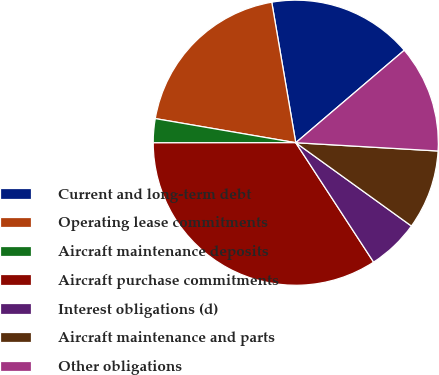Convert chart to OTSL. <chart><loc_0><loc_0><loc_500><loc_500><pie_chart><fcel>Current and long-term debt<fcel>Operating lease commitments<fcel>Aircraft maintenance deposits<fcel>Aircraft purchase commitments<fcel>Interest obligations (d)<fcel>Aircraft maintenance and parts<fcel>Other obligations<nl><fcel>16.46%<fcel>19.6%<fcel>2.72%<fcel>34.18%<fcel>5.87%<fcel>9.01%<fcel>12.16%<nl></chart> 